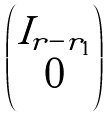Convert formula to latex. <formula><loc_0><loc_0><loc_500><loc_500>\begin{pmatrix} I _ { r - r _ { 1 } } \\ 0 \end{pmatrix}</formula> 